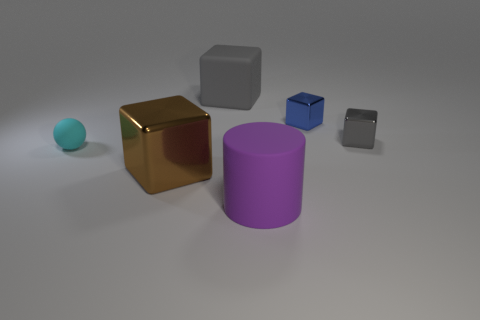Add 3 big cyan rubber blocks. How many objects exist? 9 Subtract all blue metal cubes. How many cubes are left? 3 Subtract 2 blocks. How many blocks are left? 2 Subtract all brown cylinders. Subtract all red blocks. How many cylinders are left? 1 Subtract all cyan spheres. How many yellow cylinders are left? 0 Subtract all cyan blocks. Subtract all brown shiny cubes. How many objects are left? 5 Add 3 large gray rubber things. How many large gray rubber things are left? 4 Add 4 big purple metallic blocks. How many big purple metallic blocks exist? 4 Subtract all brown blocks. How many blocks are left? 3 Subtract 0 yellow blocks. How many objects are left? 6 